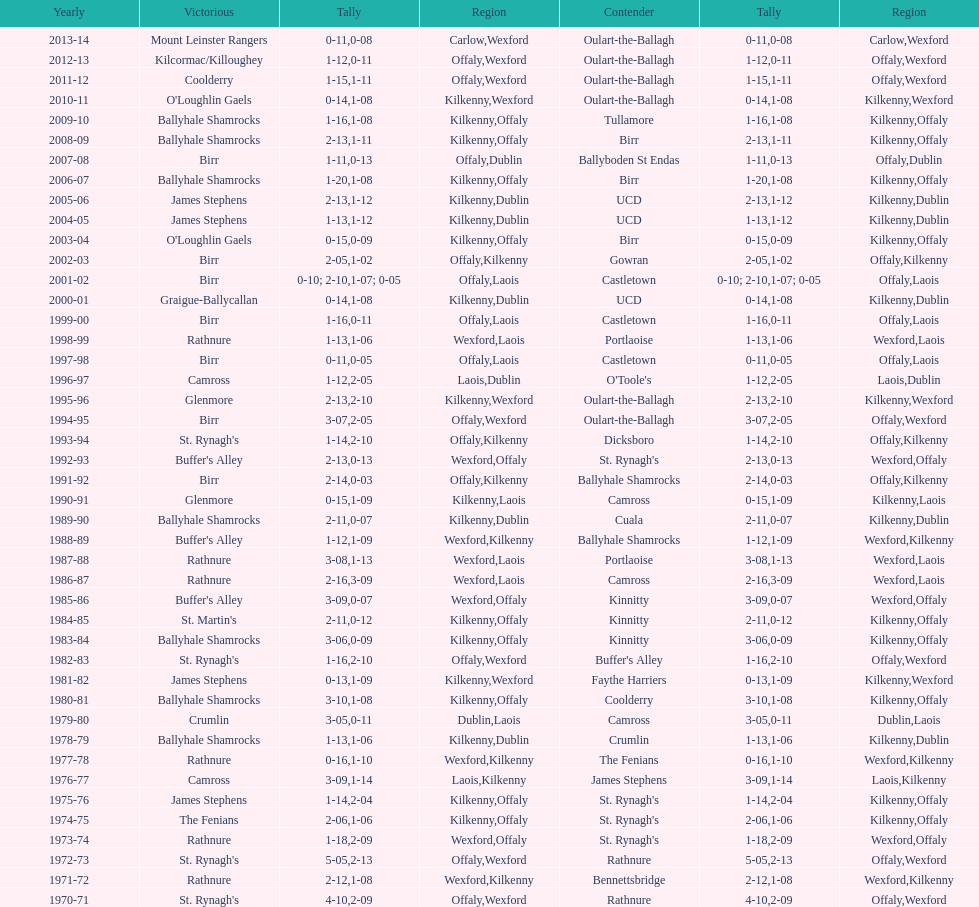Which champion is beside mount leinster rangers? Kilcormac/Killoughey. 